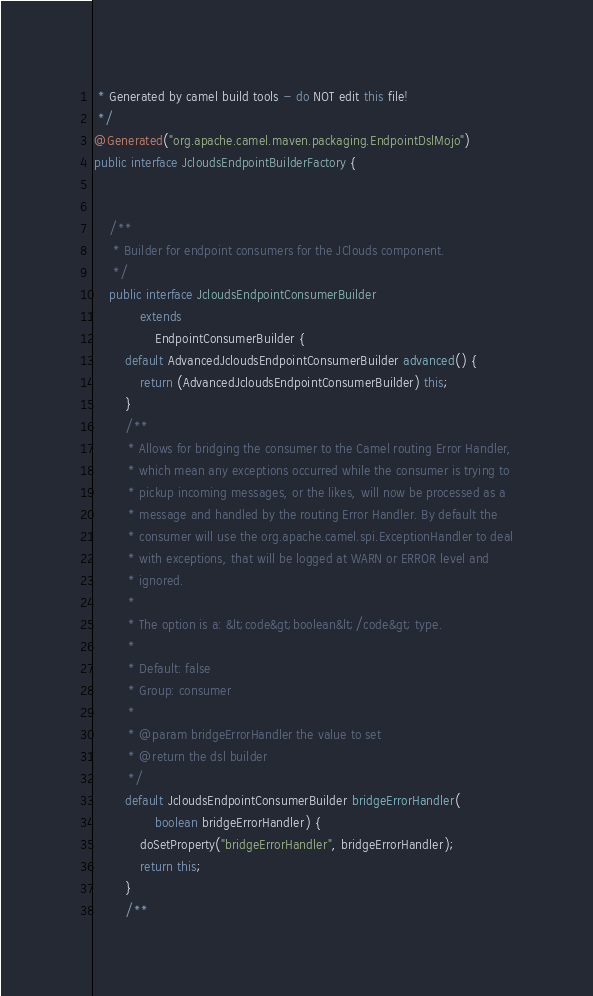<code> <loc_0><loc_0><loc_500><loc_500><_Java_> * Generated by camel build tools - do NOT edit this file!
 */
@Generated("org.apache.camel.maven.packaging.EndpointDslMojo")
public interface JcloudsEndpointBuilderFactory {


    /**
     * Builder for endpoint consumers for the JClouds component.
     */
    public interface JcloudsEndpointConsumerBuilder
            extends
                EndpointConsumerBuilder {
        default AdvancedJcloudsEndpointConsumerBuilder advanced() {
            return (AdvancedJcloudsEndpointConsumerBuilder) this;
        }
        /**
         * Allows for bridging the consumer to the Camel routing Error Handler,
         * which mean any exceptions occurred while the consumer is trying to
         * pickup incoming messages, or the likes, will now be processed as a
         * message and handled by the routing Error Handler. By default the
         * consumer will use the org.apache.camel.spi.ExceptionHandler to deal
         * with exceptions, that will be logged at WARN or ERROR level and
         * ignored.
         * 
         * The option is a: &lt;code&gt;boolean&lt;/code&gt; type.
         * 
         * Default: false
         * Group: consumer
         * 
         * @param bridgeErrorHandler the value to set
         * @return the dsl builder
         */
        default JcloudsEndpointConsumerBuilder bridgeErrorHandler(
                boolean bridgeErrorHandler) {
            doSetProperty("bridgeErrorHandler", bridgeErrorHandler);
            return this;
        }
        /**</code> 